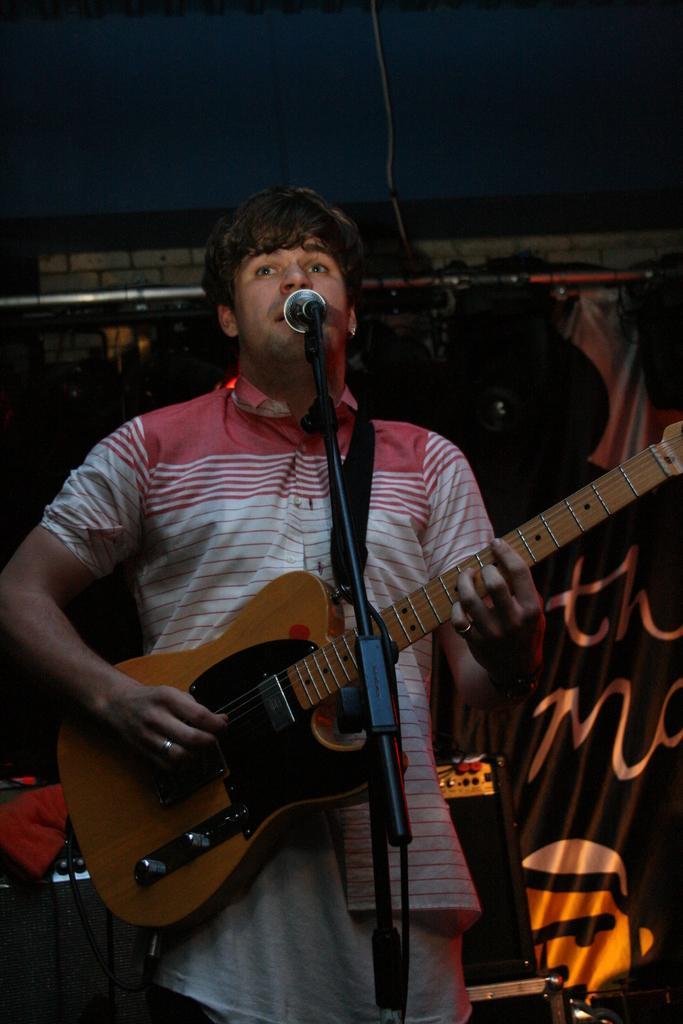Could you give a brief overview of what you see in this image? The person is playing guitar and singing in front of a mic. 